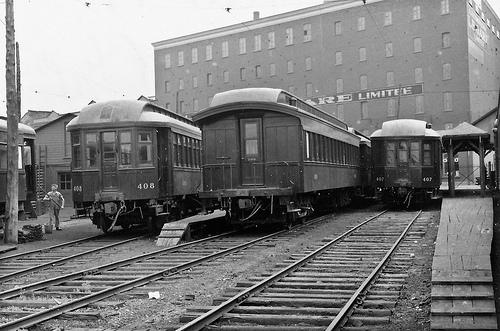Count the main elements in the image such as the train cars, the building, the platform, the man, and the tree. There are 8 main elements: 4 train cars, 1 building, 1 platform, 1 man, and 1 tree. What can you tell me about the person in the image? The person in the image is a man who is washing the train, possibly holding a stick or a cleaning tool. What is the condition of the ground in front of the train cars? The ground in front of the train cars has dirt and possibly some paper on it. What are some of the visible signs and writings in the image? There is a black and white sign on the building, numbers 408 and 407 on the train cars, and possibly some English writing on the building. Provide a detailed description of the image. The image is a black and white picture of a railway station featuring three train cars, train tracks, a platform for passengers, and a man washing the train. There are signs and numbers on the train cars and a building in the background with a ladder against it. What condition are the train station platform and ground in, and what objects are near them? The train station platform and ground have dirt on them. A staircase, wooden railroad ties, and a small roof are near them. Describe the possible interactions between the objects in the image. The man interacts with the train by washing it, people might use the platform and staircase to board the train, and the signs on the train and building provide information to the passengers. What type of image is this - color or black and white? And what is the general sentiment conveyed by the image? This is a black and white image, and it conveys a sense of nostalgia, history, and daily life around the train station. How many train cars are visible in this image, and what are the numbers written on them? There are four train cars visible in the image, with the numbers 408, 407, and two others without visible numbers. Briefly describe the setting of the image. The setting is a railway station platform with train cars on tracks, a tall building in the background, and a man cleaning the train. Identify the object that should be removed to improve the image. The missing window pane can be removed to improve the image. What are the noticeable markings on the trains? White numbers 407 and 408 can be seen on the trains. Check out the bicycle leaning against the station wall near the middle of the image. No, it's not mentioned in the image. List any structural elements in the image. Tall building, roof over part of the platform, tall palm tree, staircase, bricks on train station platform, and wooden railroad ties. Assess the quality of the image based on the given information about the objects. The image is of average quality due to the clarity of objects like the sign, train numbers, and details of objects but could be improved by increasing the resolution and adding color. Identify any interactions between objects in the image. A man is washing the train, a ladder is against the building, and there is a staircase next to the trains. Describe the surroundings of the trains in the image. There is a platform for passengers, a roof over part of the platform and a train station, train tracks and dirt on the ground, paper on the ground, a ladder against the building, and a tree nearby. What kind of tree is in the image? There is a tall palm tree in the image. What object is next to the train car? A platform, a staircase, and a man standing by the train car. Is there any text visible in the image? If so, where? Yes, there is text visible on the train (numbers 407, 408), and English writing on the building. What distinguishes the different trains in the image? Each train has different numbers, 407 and 408, and there's a container on one of the trains. Find any unusual occurrences in the image based on the given object information. A missing window pane and a man holding a stick can be considered unusual in the context of the train image. Which number is written in a larger font on the train: 407 or 408? 408 is written in a larger font on the train. Determine the sentiment behind the image based on the objects and their positions. The image evokes a sense of nostalgia as it displays old trains, a black and white sign, and is taken in black and white. Is the image in color or black and white? The image is in black and white. What does the sign on the building say? There is English writing on the building, but the exact text is not given. Are the train cars in motion? There is no indication that the train cars are in motion. What color is the sign on the building? The sign is black and white. How many trains are visible in the image? Three trains are visible. Which objects contribute the most to the overall sentiment of the image? The black and white sign, the old trains, and the black and white color of the image contribute the most. Describe the image using the given information about the objects and their positions. The image shows three trains lined up with the numbers 408, and 407 written on them, a man washing the train, a sign on the building, a platform for passengers, and a ladder against the building. 